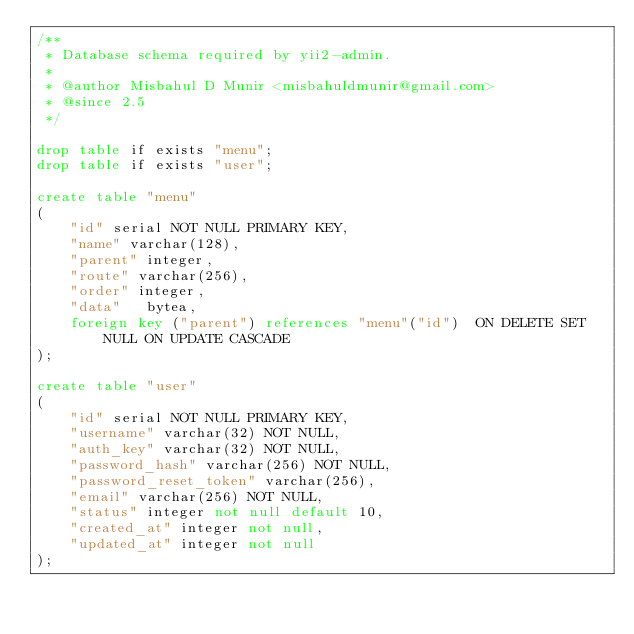Convert code to text. <code><loc_0><loc_0><loc_500><loc_500><_SQL_>/**
 * Database schema required by yii2-admin.
 *
 * @author Misbahul D Munir <misbahuldmunir@gmail.com>
 * @since 2.5
 */

drop table if exists "menu";
drop table if exists "user";

create table "menu"
(
    "id" serial NOT NULL PRIMARY KEY,
    "name" varchar(128),
    "parent" integer,
    "route" varchar(256),
    "order" integer,
    "data"   bytea,
    foreign key ("parent") references "menu"("id")  ON DELETE SET NULL ON UPDATE CASCADE
);

create table "user"
(
    "id" serial NOT NULL PRIMARY KEY,
    "username" varchar(32) NOT NULL,
    "auth_key" varchar(32) NOT NULL,
    "password_hash" varchar(256) NOT NULL,
    "password_reset_token" varchar(256),
    "email" varchar(256) NOT NULL,
    "status" integer not null default 10,
    "created_at" integer not null,
    "updated_at" integer not null
);
</code> 